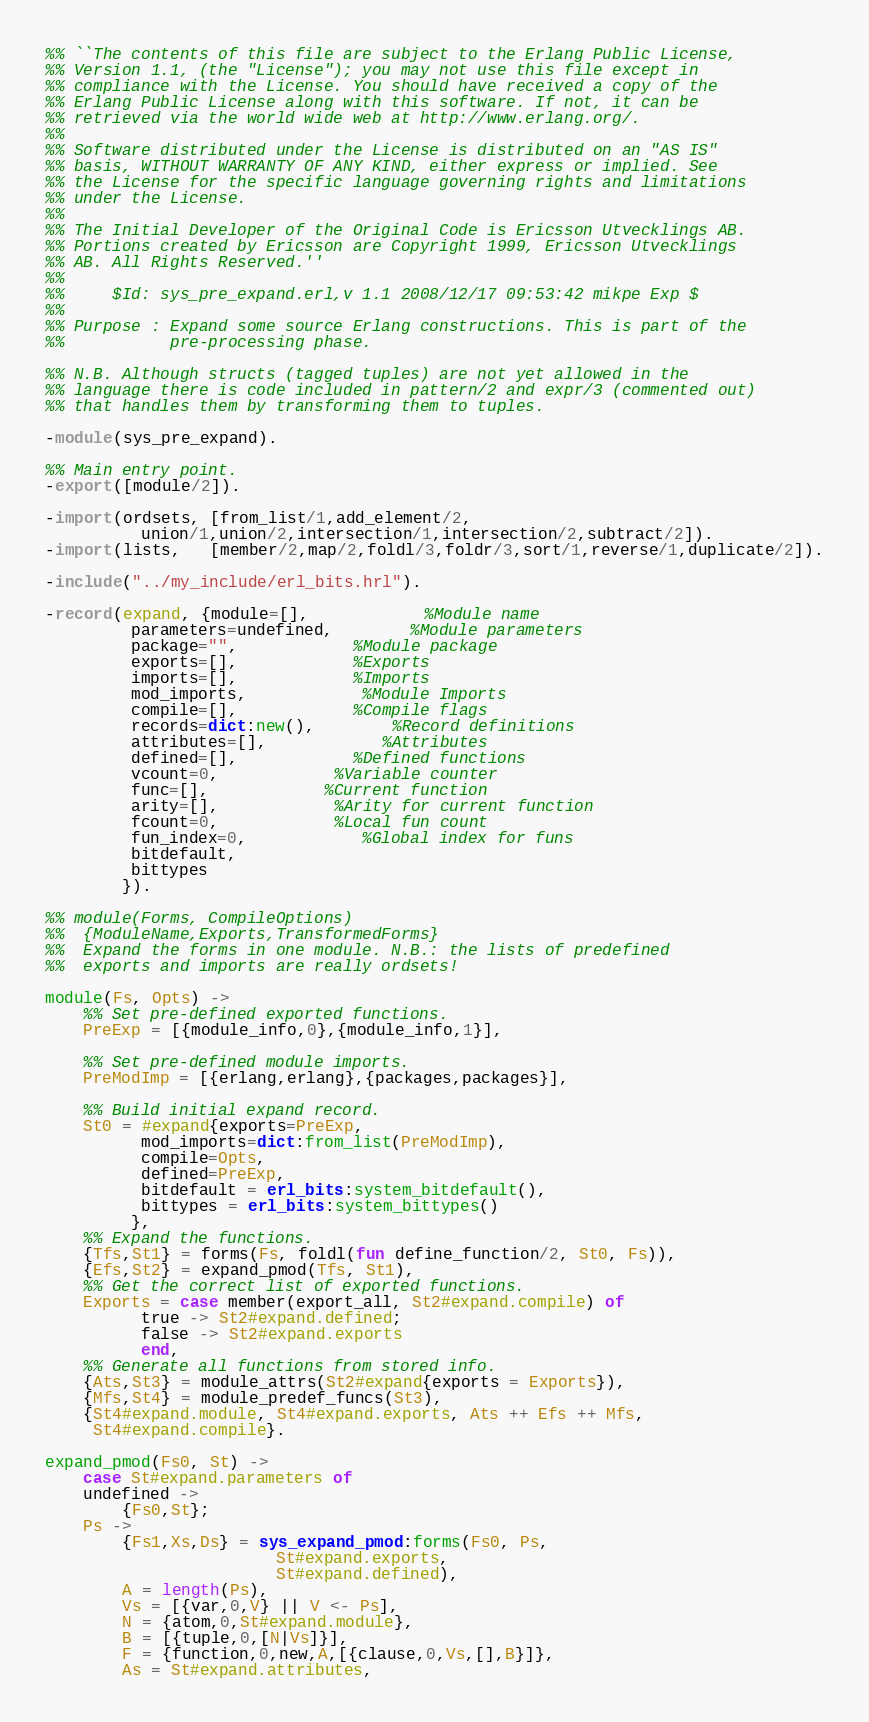Convert code to text. <code><loc_0><loc_0><loc_500><loc_500><_Erlang_>%% ``The contents of this file are subject to the Erlang Public License,
%% Version 1.1, (the "License"); you may not use this file except in
%% compliance with the License. You should have received a copy of the
%% Erlang Public License along with this software. If not, it can be
%% retrieved via the world wide web at http://www.erlang.org/.
%%
%% Software distributed under the License is distributed on an "AS IS"
%% basis, WITHOUT WARRANTY OF ANY KIND, either express or implied. See
%% the License for the specific language governing rights and limitations
%% under the License.
%%
%% The Initial Developer of the Original Code is Ericsson Utvecklings AB.
%% Portions created by Ericsson are Copyright 1999, Ericsson Utvecklings
%% AB. All Rights Reserved.''
%%
%%     $Id: sys_pre_expand.erl,v 1.1 2008/12/17 09:53:42 mikpe Exp $
%%
%% Purpose : Expand some source Erlang constructions. This is part of the
%%           pre-processing phase.

%% N.B. Although structs (tagged tuples) are not yet allowed in the
%% language there is code included in pattern/2 and expr/3 (commented out)
%% that handles them by transforming them to tuples.

-module(sys_pre_expand).

%% Main entry point.
-export([module/2]).

-import(ordsets, [from_list/1,add_element/2,
		  union/1,union/2,intersection/1,intersection/2,subtract/2]).
-import(lists,   [member/2,map/2,foldl/3,foldr/3,sort/1,reverse/1,duplicate/2]).

-include("../my_include/erl_bits.hrl").

-record(expand, {module=[],			%Module name
		 parameters=undefined,		%Module parameters
		 package="",			%Module package
		 exports=[],			%Exports
		 imports=[],			%Imports
		 mod_imports,			%Module Imports
		 compile=[],			%Compile flags
		 records=dict:new(),		%Record definitions
		 attributes=[],			%Attributes
		 defined=[],			%Defined functions
		 vcount=0,			%Variable counter
		 func=[],			%Current function
		 arity=[],			%Arity for current function
		 fcount=0,			%Local fun count
		 fun_index=0,			%Global index for funs
		 bitdefault,
		 bittypes
		}).

%% module(Forms, CompileOptions)
%%	{ModuleName,Exports,TransformedForms}
%%  Expand the forms in one module. N.B.: the lists of predefined
%%  exports and imports are really ordsets!

module(Fs, Opts) ->
    %% Set pre-defined exported functions.
    PreExp = [{module_info,0},{module_info,1}],

    %% Set pre-defined module imports.
    PreModImp = [{erlang,erlang},{packages,packages}],

    %% Build initial expand record.
    St0 = #expand{exports=PreExp,
		  mod_imports=dict:from_list(PreModImp),
		  compile=Opts,
		  defined=PreExp,
		  bitdefault = erl_bits:system_bitdefault(),
		  bittypes = erl_bits:system_bittypes()
		 },
    %% Expand the functions.
    {Tfs,St1} = forms(Fs, foldl(fun define_function/2, St0, Fs)),
    {Efs,St2} = expand_pmod(Tfs, St1),
    %% Get the correct list of exported functions.
    Exports = case member(export_all, St2#expand.compile) of
		  true -> St2#expand.defined;
		  false -> St2#expand.exports
	      end,
    %% Generate all functions from stored info.
    {Ats,St3} = module_attrs(St2#expand{exports = Exports}),
    {Mfs,St4} = module_predef_funcs(St3),
    {St4#expand.module, St4#expand.exports, Ats ++ Efs ++ Mfs,
     St4#expand.compile}.

expand_pmod(Fs0, St) ->
    case St#expand.parameters of
	undefined ->
	    {Fs0,St};
	Ps ->
	    {Fs1,Xs,Ds} = sys_expand_pmod:forms(Fs0, Ps,
						St#expand.exports,
						St#expand.defined),
	    A = length(Ps),
	    Vs = [{var,0,V} || V <- Ps],
	    N = {atom,0,St#expand.module},
	    B = [{tuple,0,[N|Vs]}],
	    F = {function,0,new,A,[{clause,0,Vs,[],B}]},
	    As = St#expand.attributes,</code> 